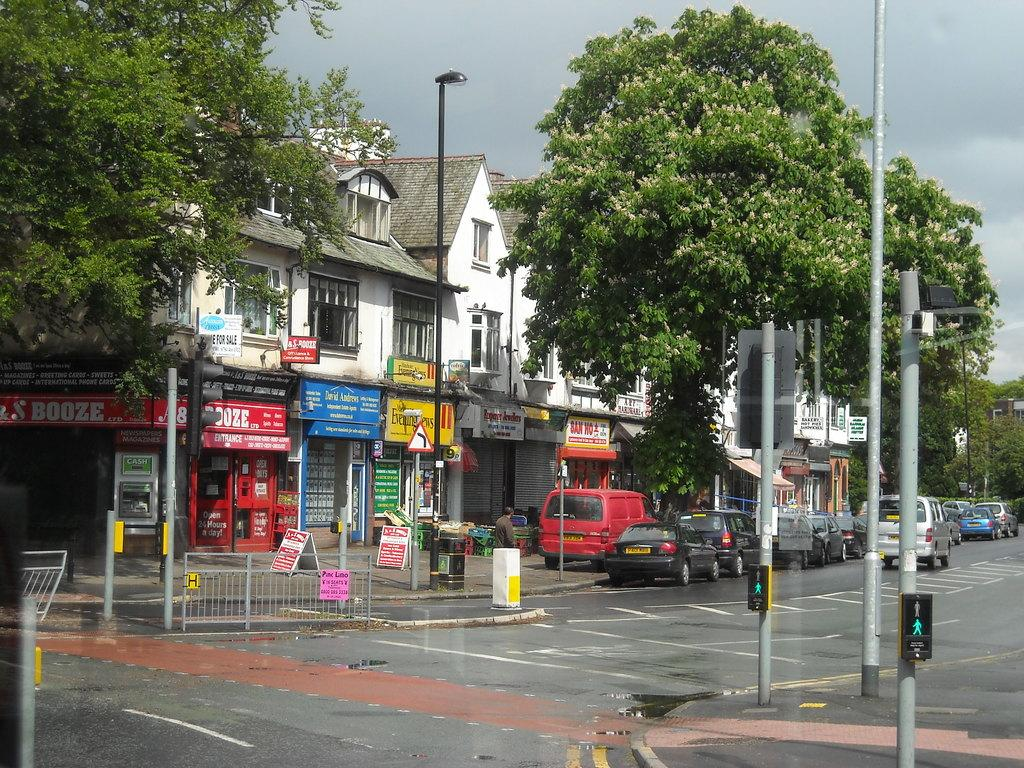<image>
Describe the image concisely. a street with shops on it like San Ho and S Booze 